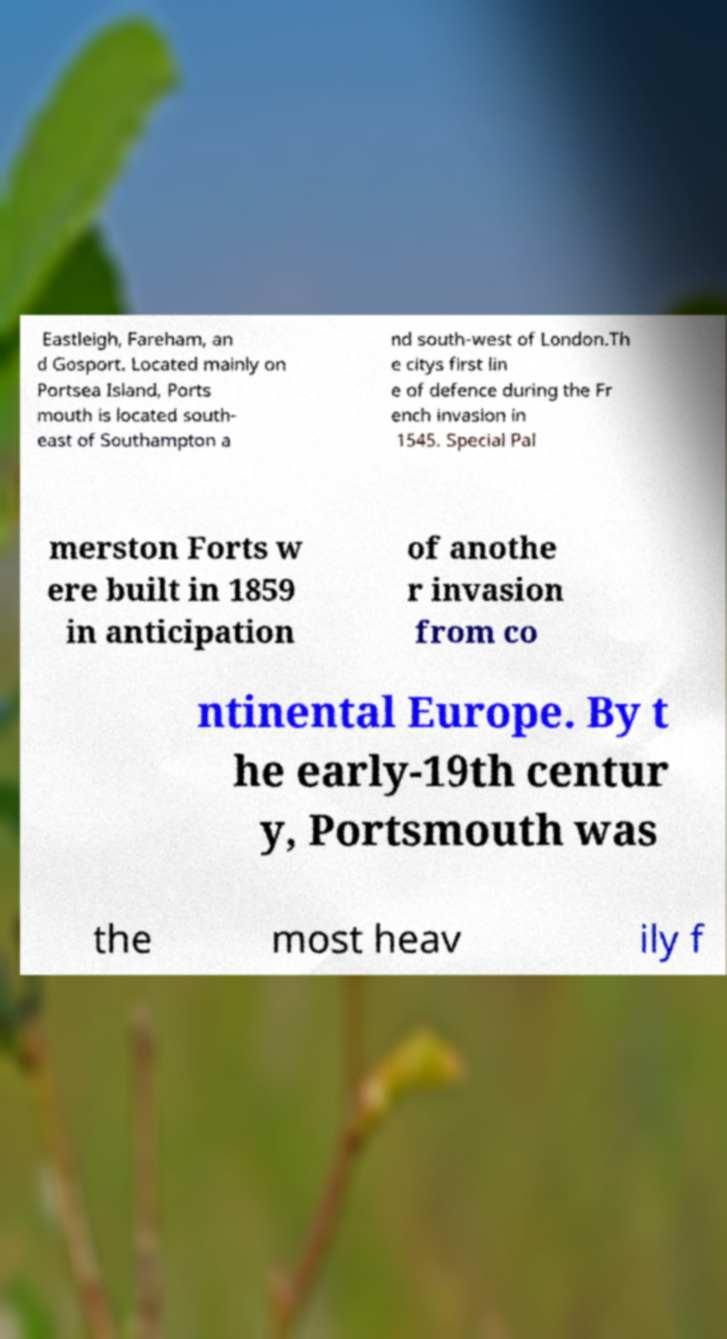Could you extract and type out the text from this image? Eastleigh, Fareham, an d Gosport. Located mainly on Portsea Island, Ports mouth is located south- east of Southampton a nd south-west of London.Th e citys first lin e of defence during the Fr ench invasion in 1545. Special Pal merston Forts w ere built in 1859 in anticipation of anothe r invasion from co ntinental Europe. By t he early-19th centur y, Portsmouth was the most heav ily f 